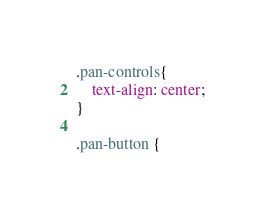<code> <loc_0><loc_0><loc_500><loc_500><_CSS_>
.pan-controls{
    text-align: center;
}

.pan-button {</code> 